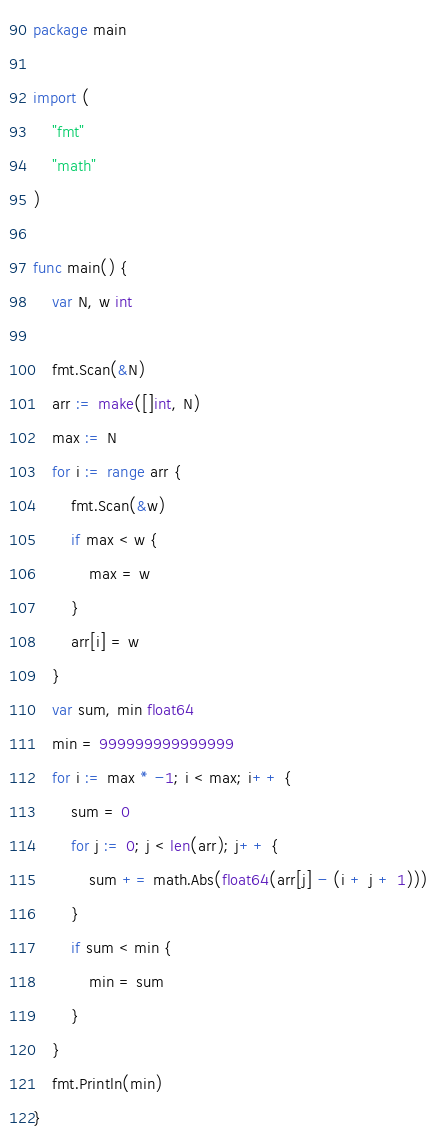Convert code to text. <code><loc_0><loc_0><loc_500><loc_500><_Go_>package main

import (
	"fmt"
	"math"
)

func main() {
	var N, w int

	fmt.Scan(&N)
	arr := make([]int, N)
	max := N
	for i := range arr {
		fmt.Scan(&w)
		if max < w {
			max = w
		}
		arr[i] = w
	}
	var sum, min float64
	min = 999999999999999
	for i := max * -1; i < max; i++ {
		sum = 0
		for j := 0; j < len(arr); j++ {
			sum += math.Abs(float64(arr[j] - (i + j + 1)))
		}
		if sum < min {
			min = sum
		}
	}
	fmt.Println(min)
}</code> 